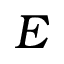<formula> <loc_0><loc_0><loc_500><loc_500>E</formula> 